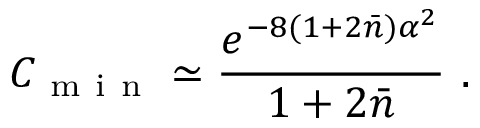<formula> <loc_0><loc_0><loc_500><loc_500>C _ { m i n } \simeq \frac { e ^ { - 8 ( 1 + 2 \bar { n } ) \alpha ^ { 2 } } } { 1 + 2 \bar { n } } \ .</formula> 